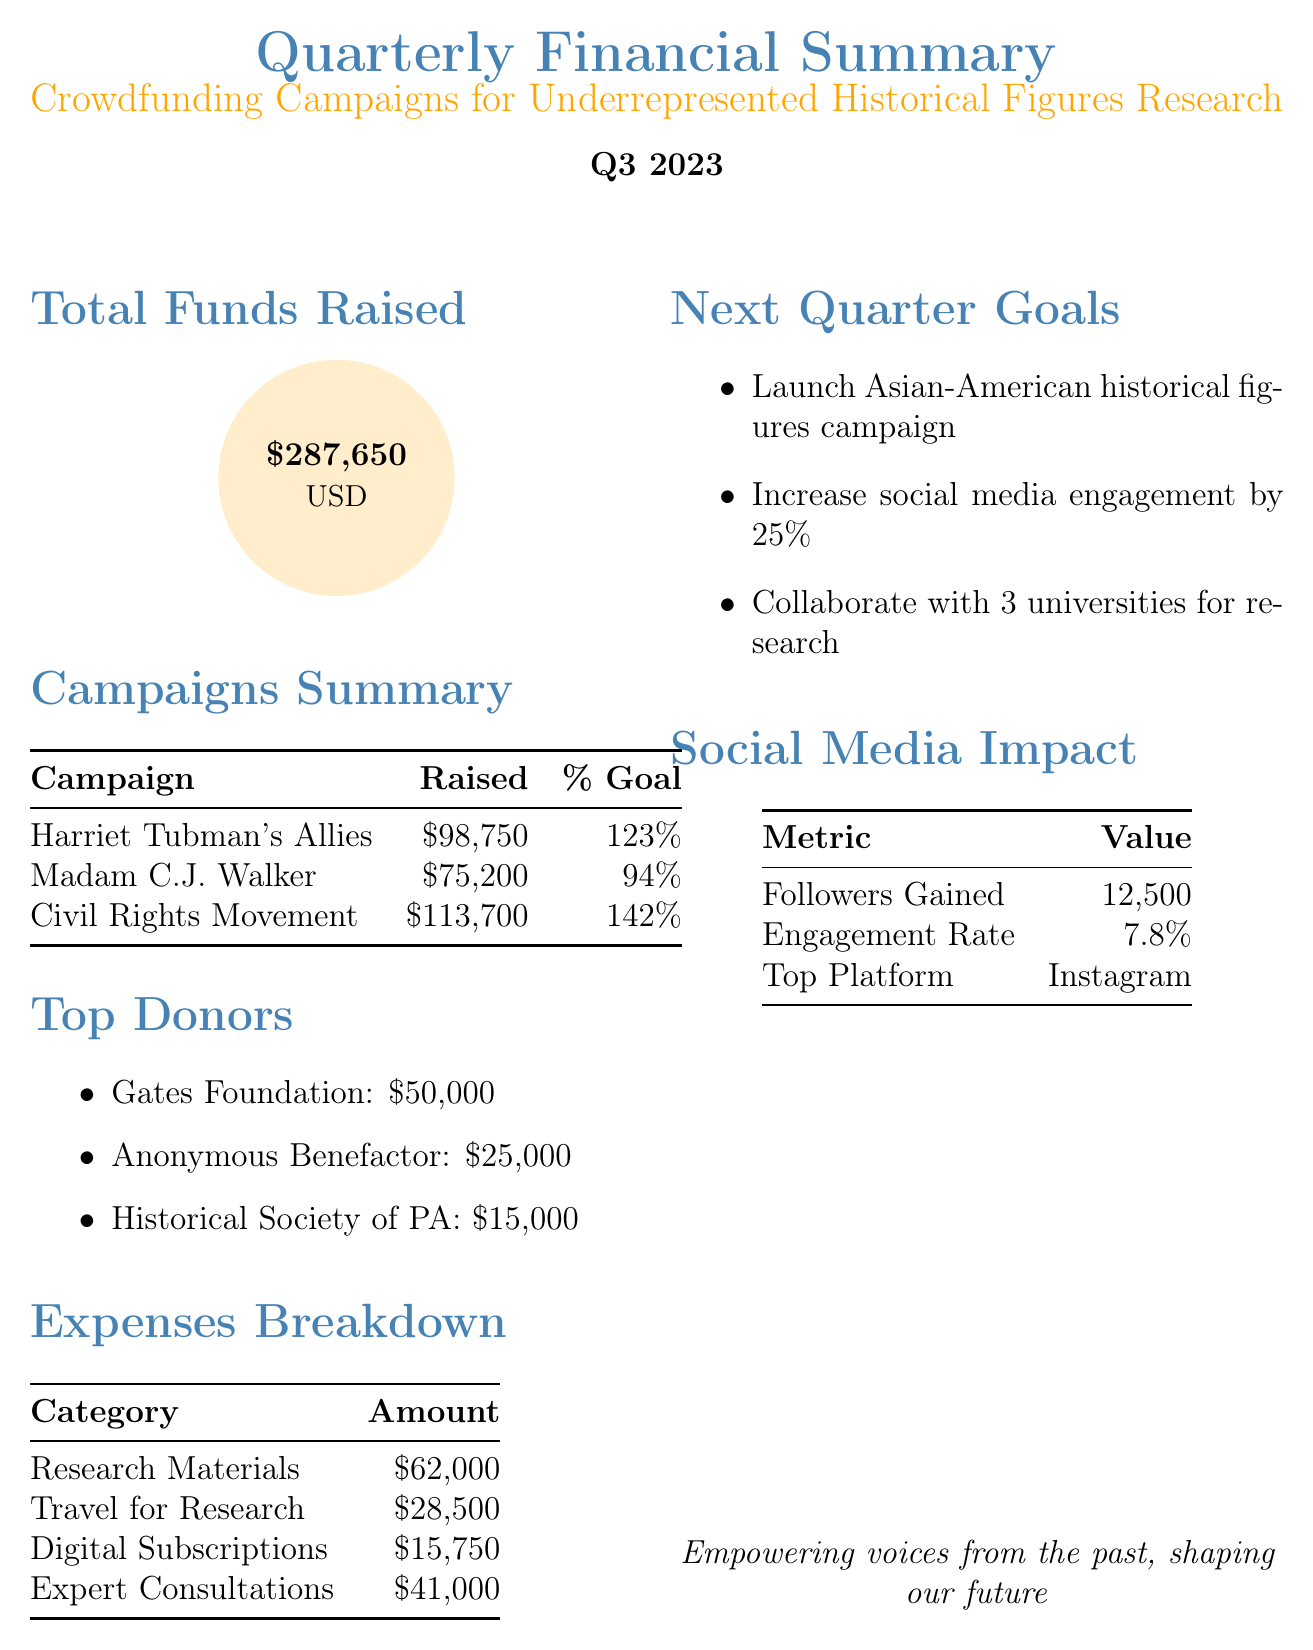What is the total funds raised? The total funds raised is the sum of all funds collected from the campaigns, which totals 287650 USD.
Answer: 287650 Which campaign raised the most funds? The campaign "Hidden Figures of the Civil Rights Movement" raised the highest amount at 113700 USD.
Answer: Hidden Figures of the Civil Rights Movement What percentage of their goal did Madam C.J. Walker’s campaign reach? The percentage of the goal for "Madam C.J. Walker: Beyond Beauty" is noted as 94%.
Answer: 94 What is the total amount spent on travel for on-site research? The document lists the expense for travel for on-site research as 28500 USD.
Answer: 28500 Who is the top donor? The top donor listed in the document is the Gates Foundation, contributing 50000 USD.
Answer: Gates Foundation How many followers were gained in the last quarter? The report states that 12500 followers were gained during the quarter.
Answer: 12500 What is the engagement rate of the campaigns on social media? The engagement rate of the campaigns is reported as 7.8%.
Answer: 7.8 What is one of the goals for the next quarter? One of the goals for the next quarter includes launching a campaign for Asian-American historical figures.
Answer: Launch campaign for Asian-American historical figures What was the total amount spent on research materials? The document specifies that the spending on research materials totaled 62000 USD.
Answer: 62000 